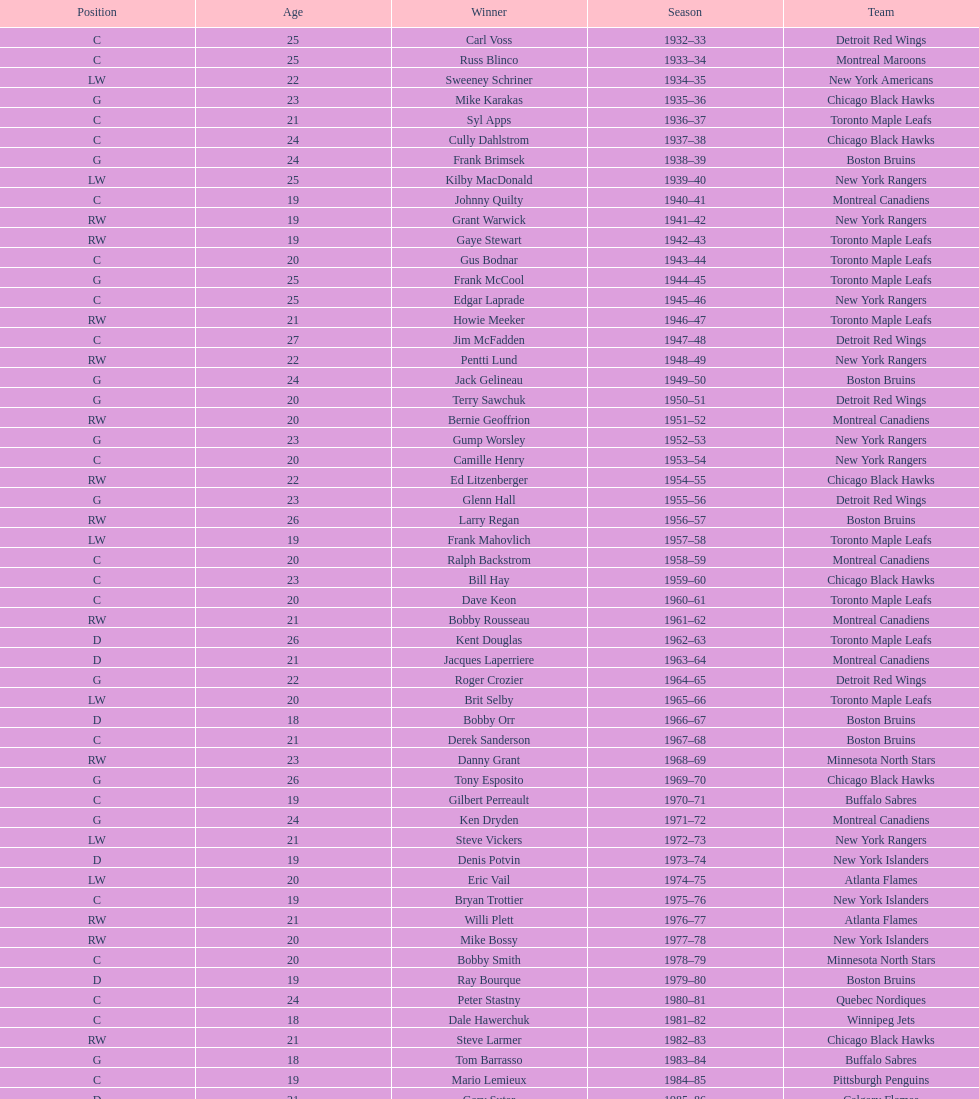Which team has the highest number of consecutive calder memorial trophy winners? Toronto Maple Leafs. 